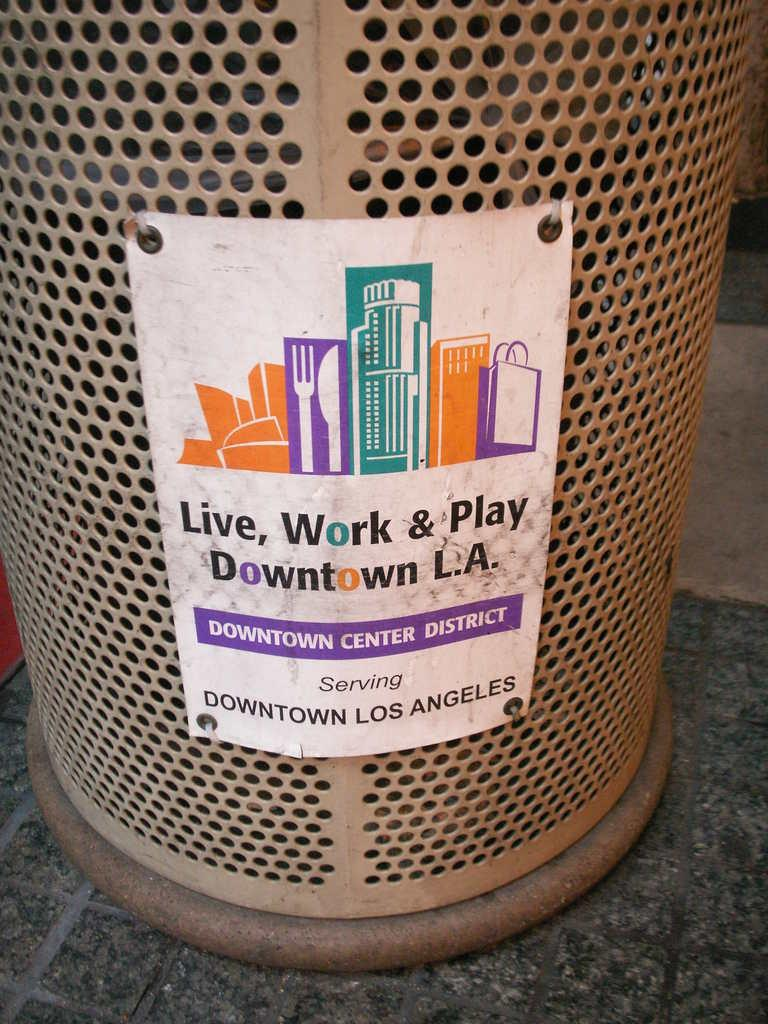<image>
Provide a brief description of the given image. A trash can in downtown Los Angeles has a cartoon picture of city buildings on it. 